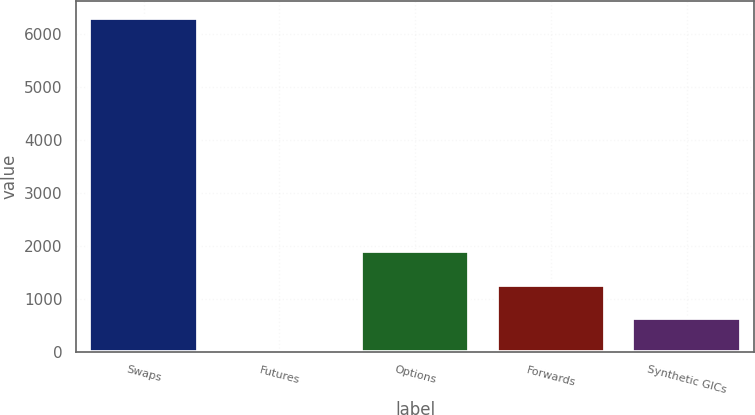<chart> <loc_0><loc_0><loc_500><loc_500><bar_chart><fcel>Swaps<fcel>Futures<fcel>Options<fcel>Forwards<fcel>Synthetic GICs<nl><fcel>6316<fcel>6<fcel>1899<fcel>1268<fcel>637<nl></chart> 